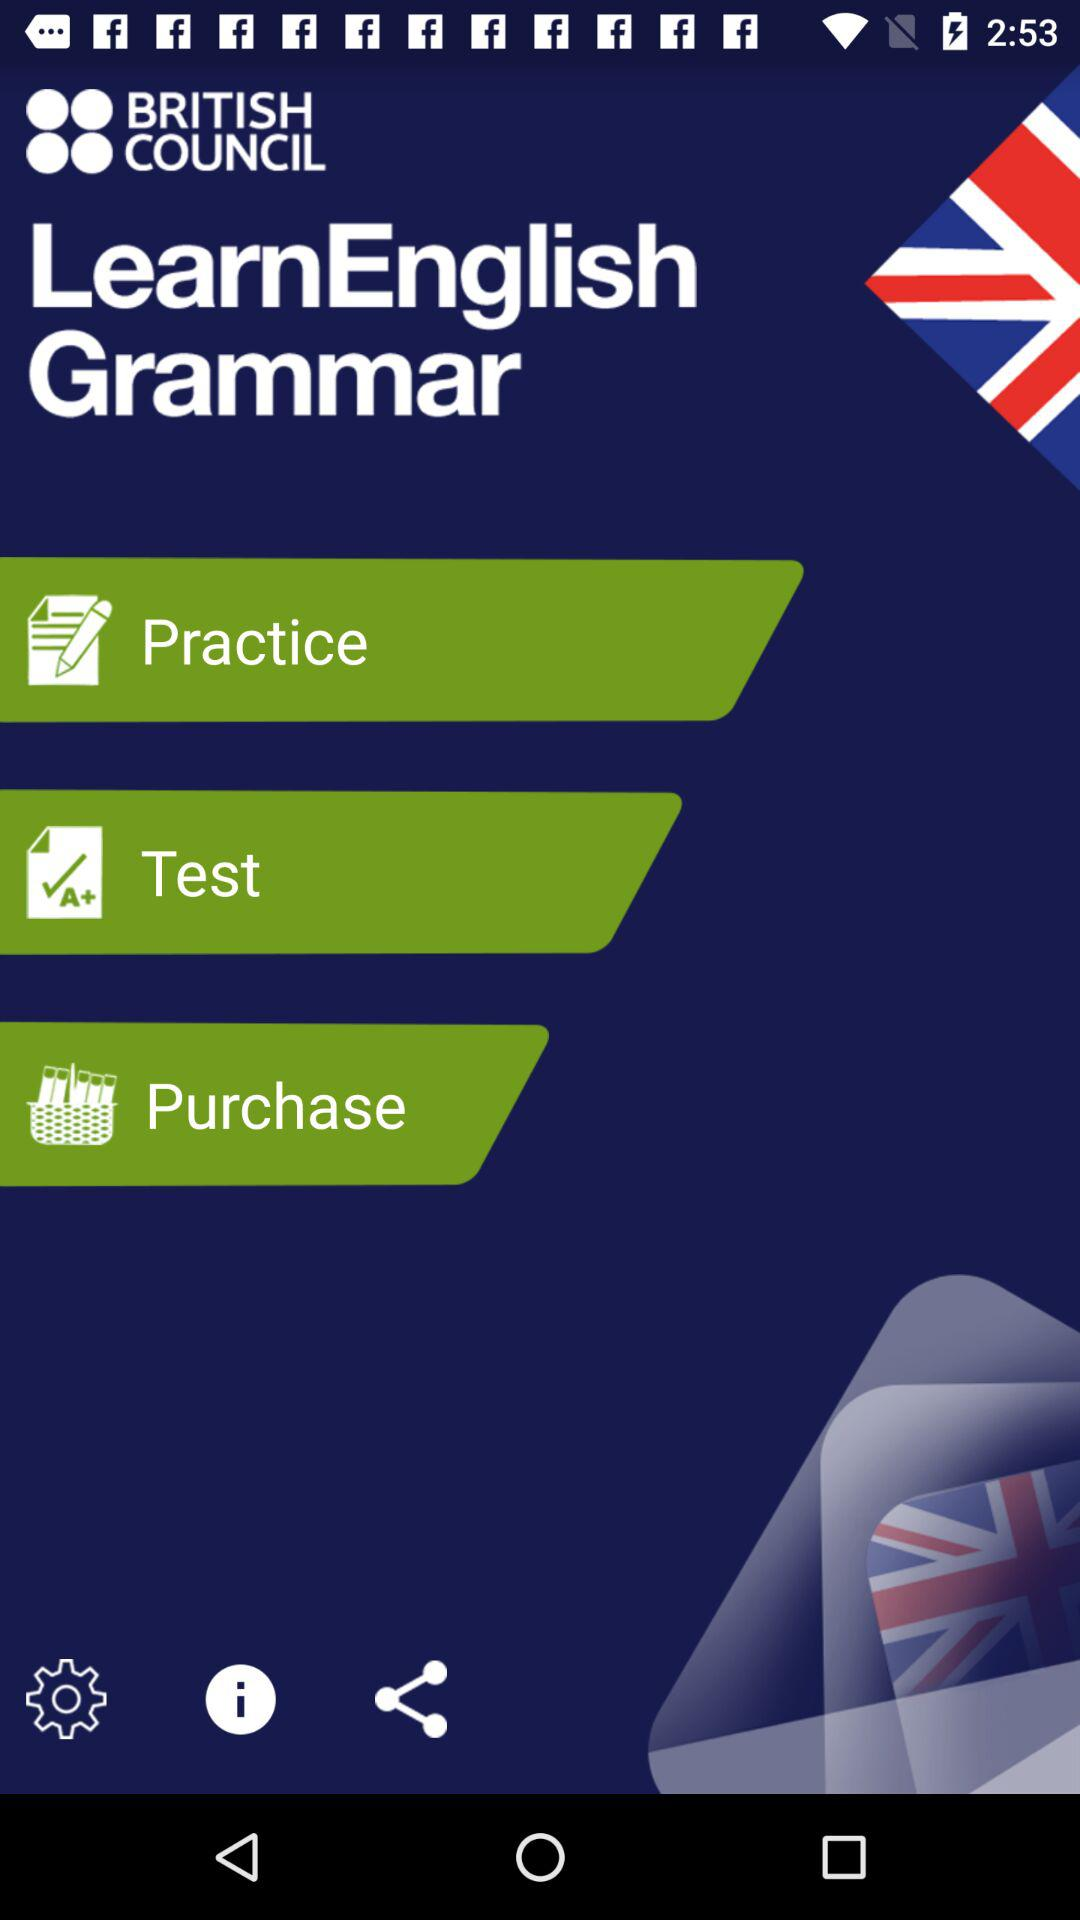What is the app name? The app name is "BRITISH COUNCIL". 